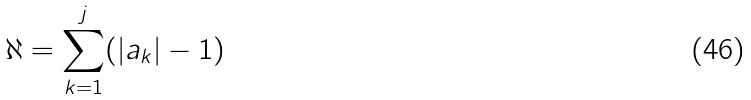Convert formula to latex. <formula><loc_0><loc_0><loc_500><loc_500>\aleph = \sum _ { k = 1 } ^ { j } ( | a _ { k } | - 1 )</formula> 